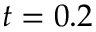Convert formula to latex. <formula><loc_0><loc_0><loc_500><loc_500>t = 0 . 2</formula> 